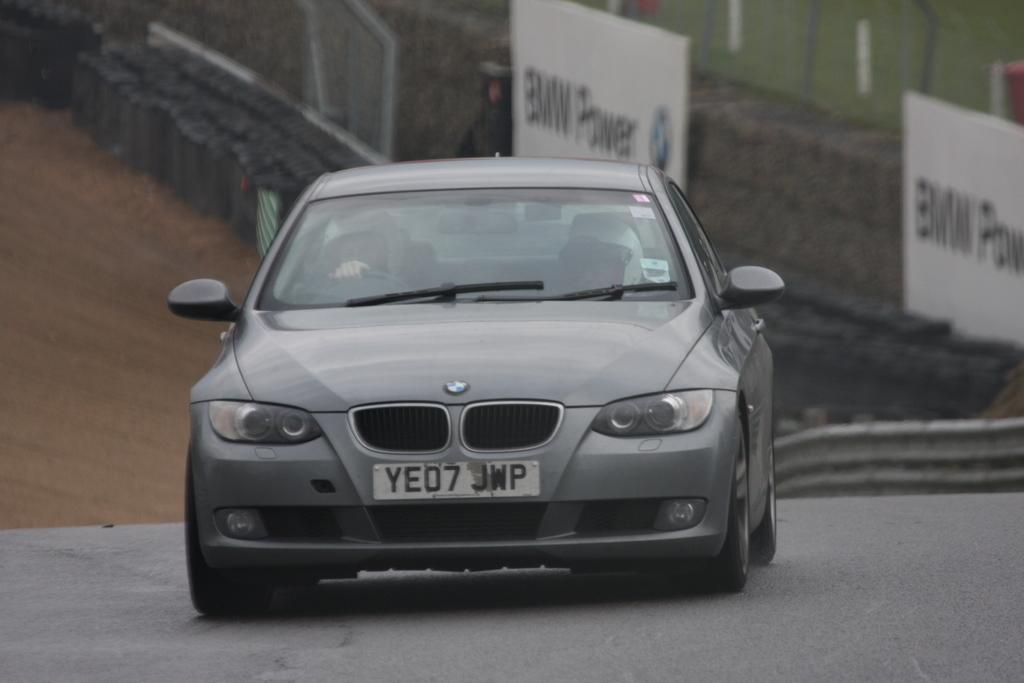What is the main subject of the image? There is a car on the road in the image. Who or what is inside the car? There are people sitting inside the car. What can be seen on the land in the image? There are objects on the land in the image. What is visible in the background of the image? There is a wall with banners in the background of the image. Where is the fence located in the image? There is a fence visible at the top right of the image. What type of ship can be seen sailing in the image? There is no ship present in the image; it features a car on the road. How many letters are visible on the banners in the image? The number of letters on the banners cannot be determined from the image alone, as the text is not legible. 